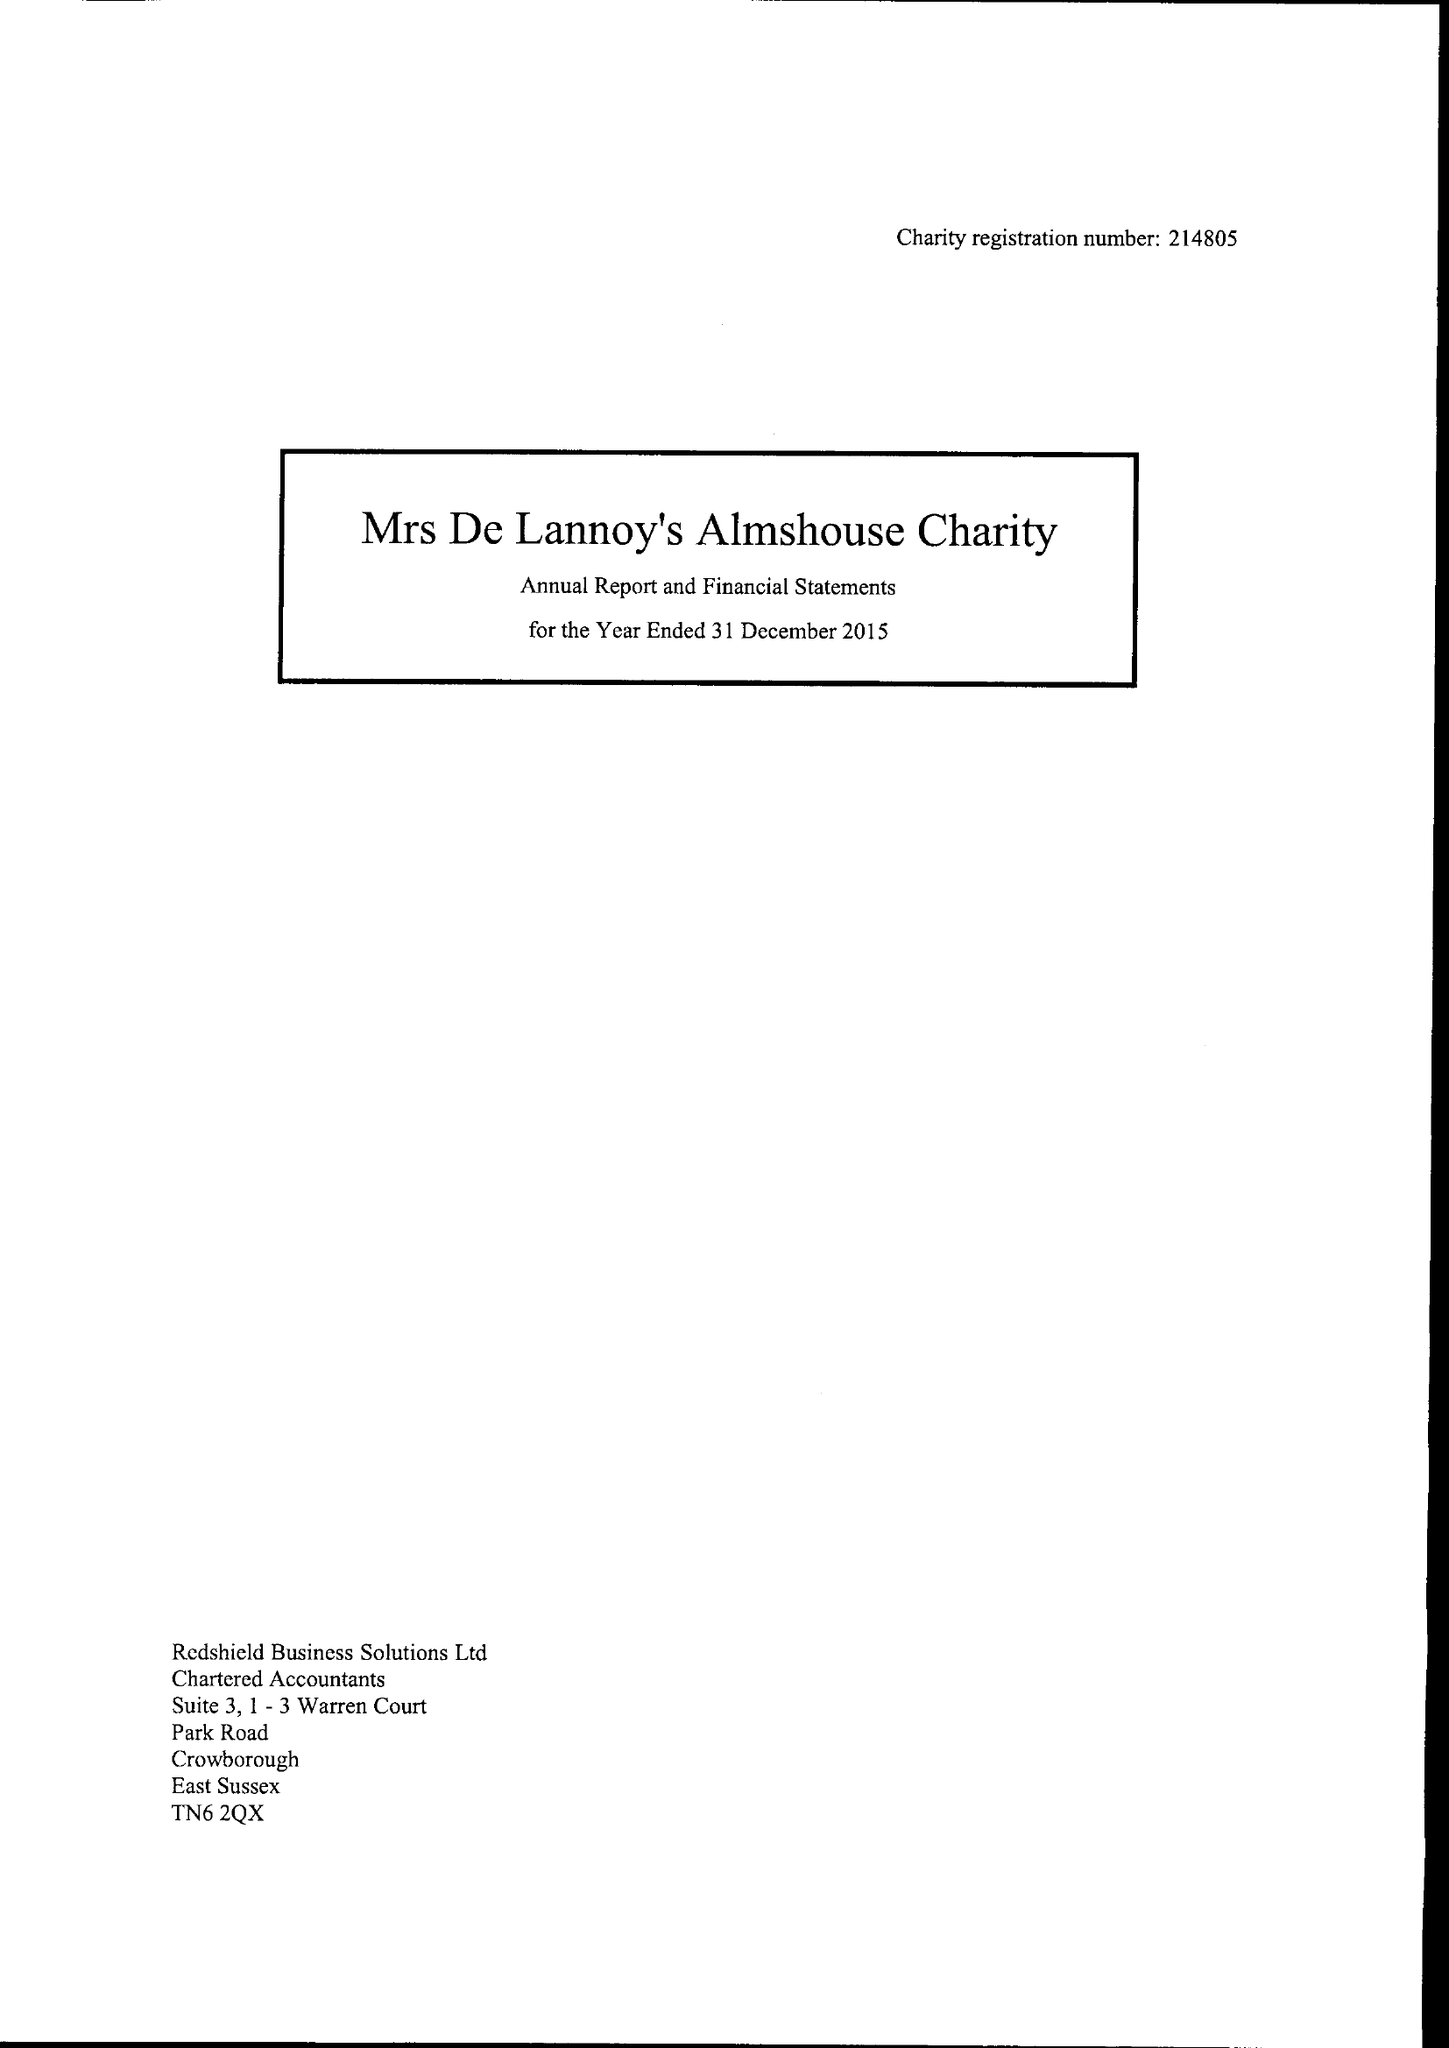What is the value for the charity_number?
Answer the question using a single word or phrase. 214805 